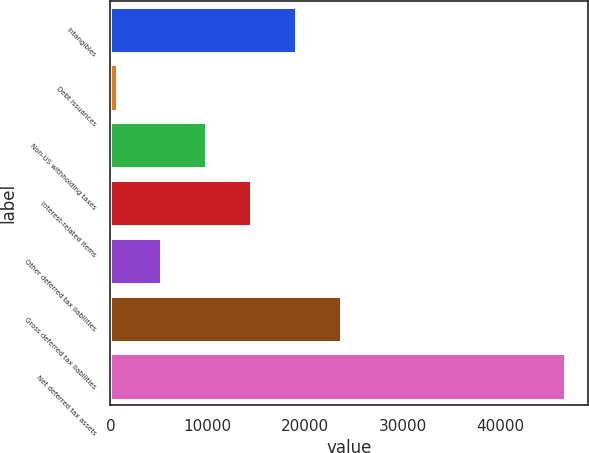<chart> <loc_0><loc_0><loc_500><loc_500><bar_chart><fcel>Intangibles<fcel>Debt issuances<fcel>Non-US withholding taxes<fcel>Interest-related items<fcel>Other deferred tax liabilities<fcel>Gross deferred tax liabilities<fcel>Net deferred tax assets<nl><fcel>19051.8<fcel>641<fcel>9846.4<fcel>14449.1<fcel>5243.7<fcel>23654.5<fcel>46668<nl></chart> 